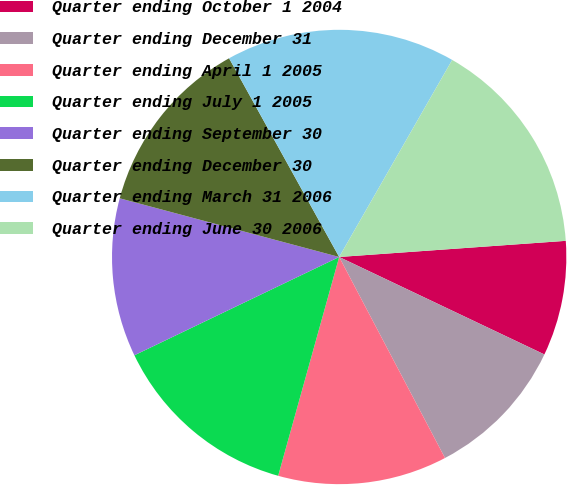<chart> <loc_0><loc_0><loc_500><loc_500><pie_chart><fcel>Quarter ending October 1 2004<fcel>Quarter ending December 31<fcel>Quarter ending April 1 2005<fcel>Quarter ending July 1 2005<fcel>Quarter ending September 30<fcel>Quarter ending December 30<fcel>Quarter ending March 31 2006<fcel>Quarter ending June 30 2006<nl><fcel>8.19%<fcel>10.23%<fcel>12.04%<fcel>13.55%<fcel>11.28%<fcel>12.79%<fcel>16.34%<fcel>15.58%<nl></chart> 